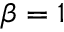<formula> <loc_0><loc_0><loc_500><loc_500>\beta = 1</formula> 